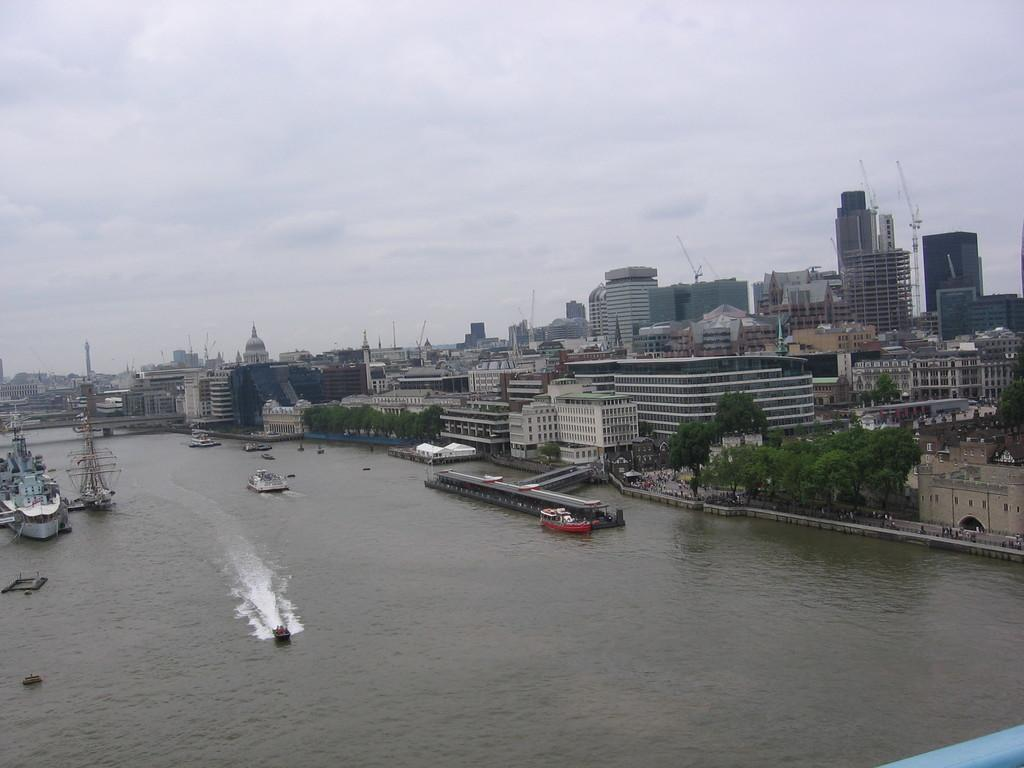What type of vehicles can be seen on the water in the image? There are ships on the water in the image. What type of natural vegetation is visible in the image? There are trees visible in the image. What type of man-made structures can be seen in the image? There are buildings visible in the image. Can you see a bridge connecting the trees in the image? There is no bridge connecting the trees in the image; only ships, trees, and buildings are present. Are there any bats flying around the ships in the image? There is no indication of bats in the image; only ships, trees, and buildings are present. 